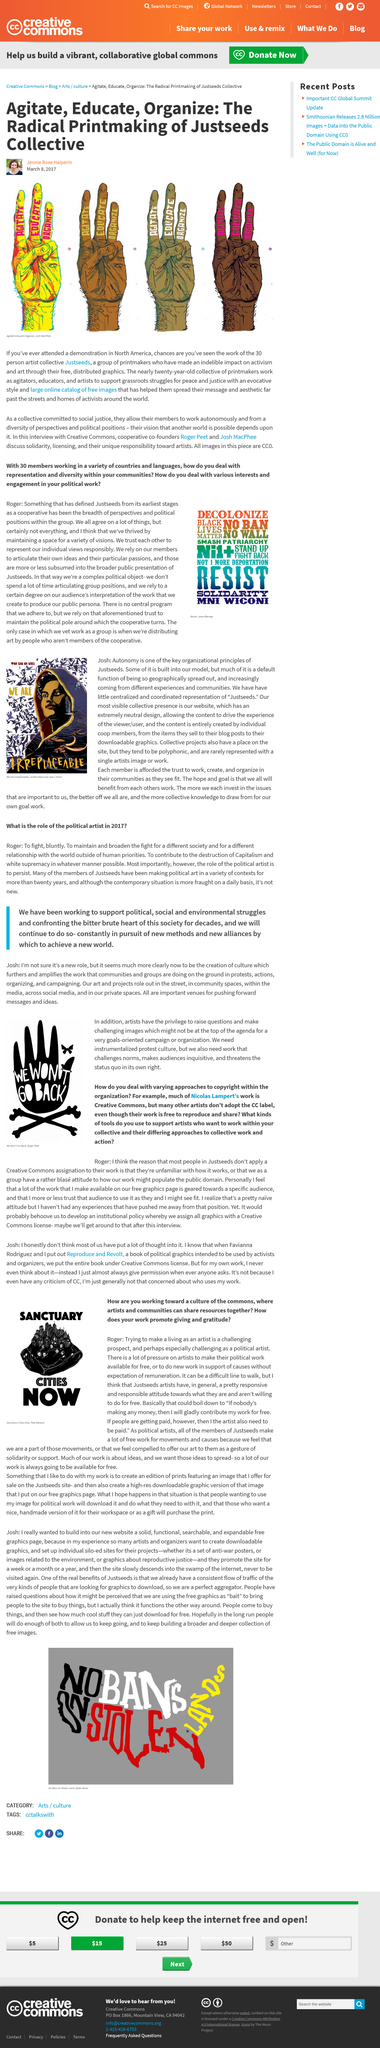Draw attention to some important aspects in this diagram. The phrase 'We Won't Go Back' is shown in the photo, which clearly communicates the sentiment that the subject will not retreat or relinquish their goals or values. Thirty individuals are collectively part of Justseeds. The main image is titled "Agitate-Educate-Organize." Roger Peet was the creator of the "We Won't Go Back" logo. Nicolas Lampert's work is Creative Commons, with much of it being licensed under this creative commons license. 